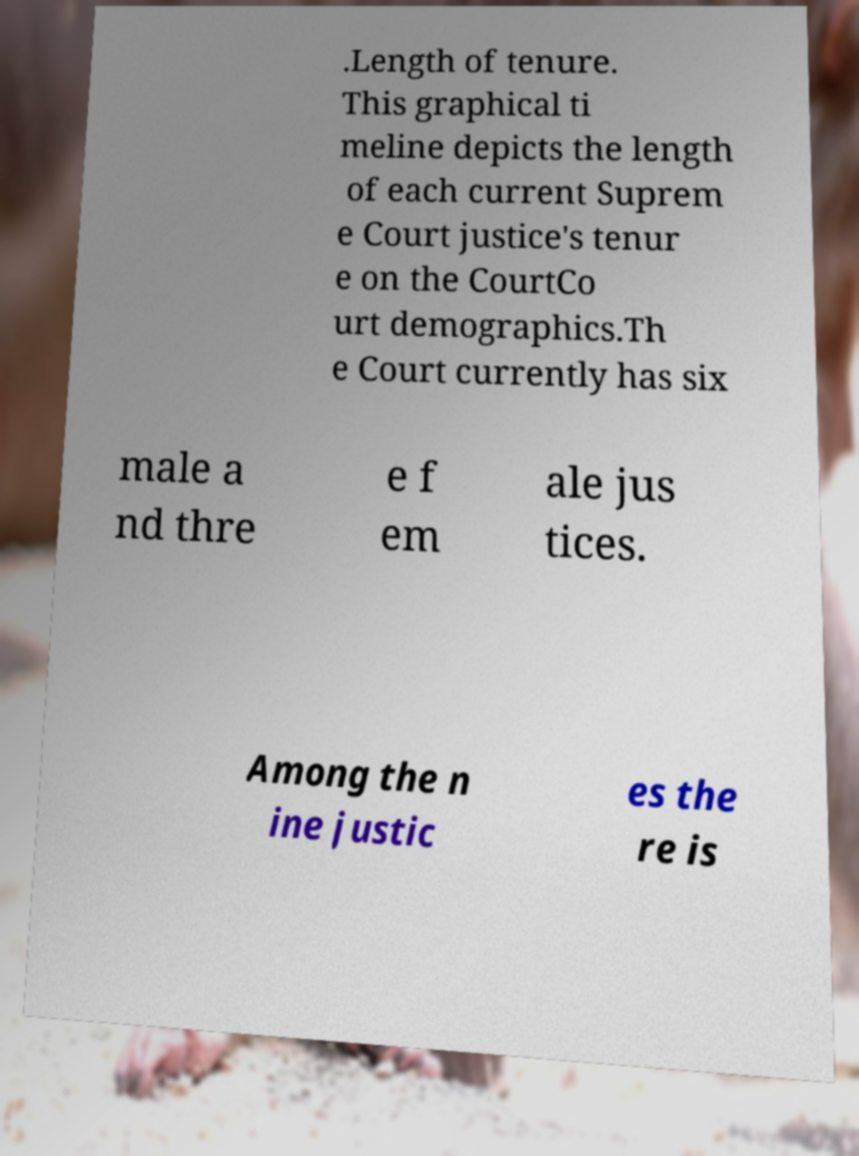Could you assist in decoding the text presented in this image and type it out clearly? .Length of tenure. This graphical ti meline depicts the length of each current Suprem e Court justice's tenur e on the CourtCo urt demographics.Th e Court currently has six male a nd thre e f em ale jus tices. Among the n ine justic es the re is 